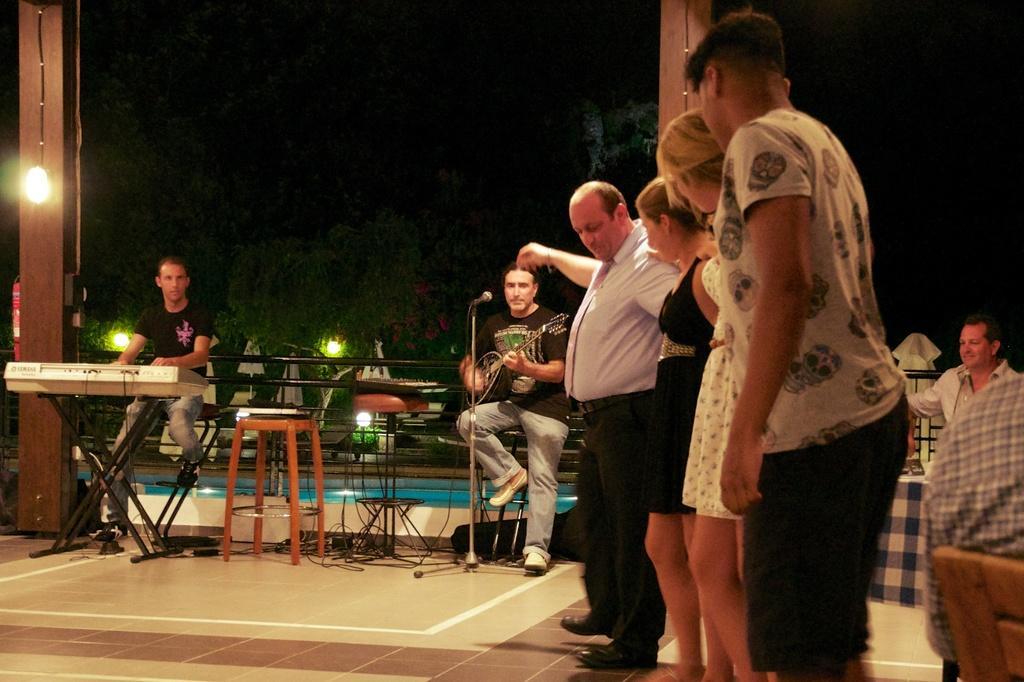Please provide a concise description of this image. in this image there are some people standing on the floor and some people are sitting on the chair and playing some instruments and behind the persons there is one swimming pool and some trees are their background is very dark. 